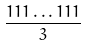<formula> <loc_0><loc_0><loc_500><loc_500>\frac { 1 1 1 \dots 1 1 1 } { 3 }</formula> 